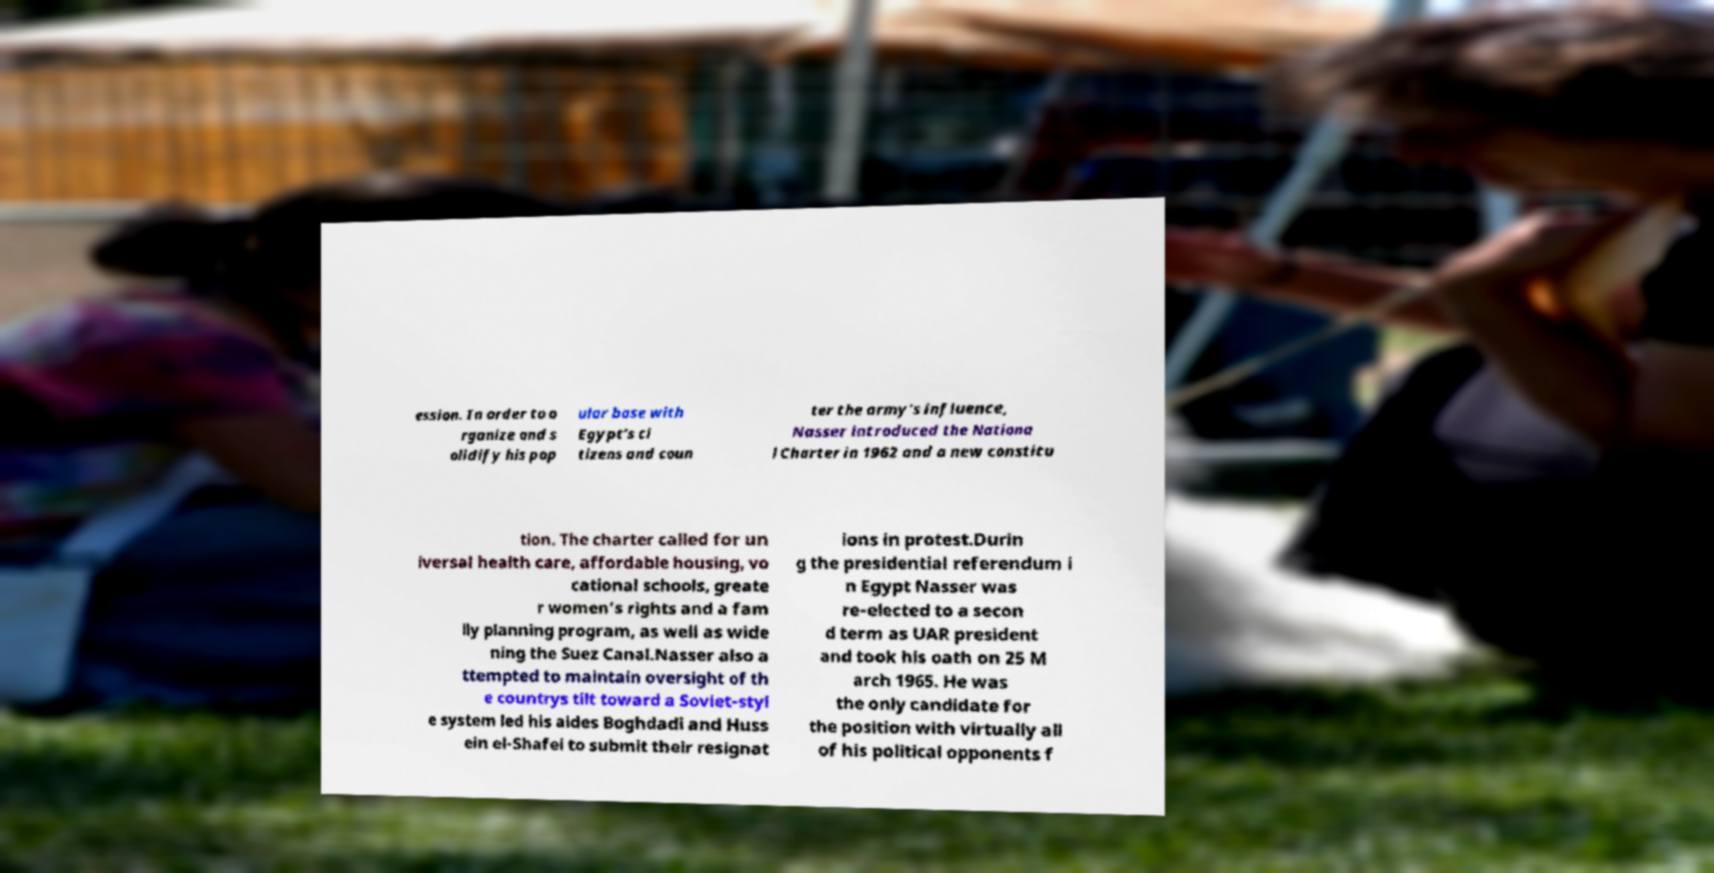I need the written content from this picture converted into text. Can you do that? ession. In order to o rganize and s olidify his pop ular base with Egypt's ci tizens and coun ter the army's influence, Nasser introduced the Nationa l Charter in 1962 and a new constitu tion. The charter called for un iversal health care, affordable housing, vo cational schools, greate r women's rights and a fam ily planning program, as well as wide ning the Suez Canal.Nasser also a ttempted to maintain oversight of th e countrys tilt toward a Soviet-styl e system led his aides Boghdadi and Huss ein el-Shafei to submit their resignat ions in protest.Durin g the presidential referendum i n Egypt Nasser was re-elected to a secon d term as UAR president and took his oath on 25 M arch 1965. He was the only candidate for the position with virtually all of his political opponents f 